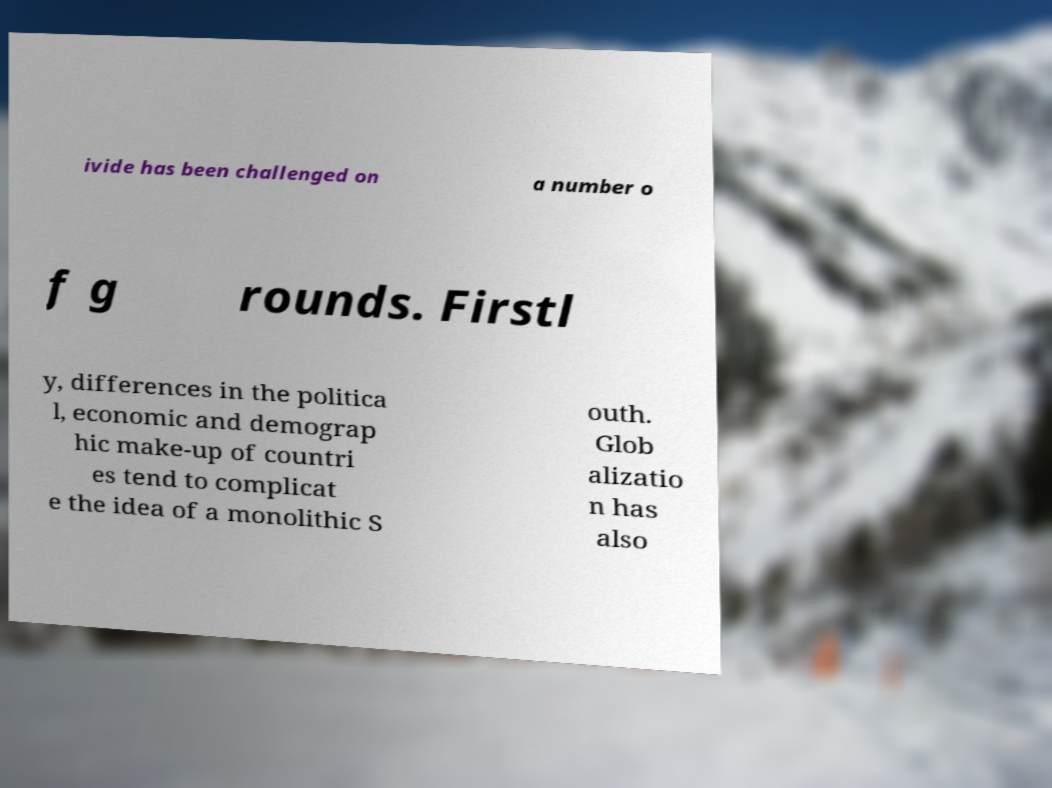Please identify and transcribe the text found in this image. ivide has been challenged on a number o f g rounds. Firstl y, differences in the politica l, economic and demograp hic make-up of countri es tend to complicat e the idea of a monolithic S outh. Glob alizatio n has also 